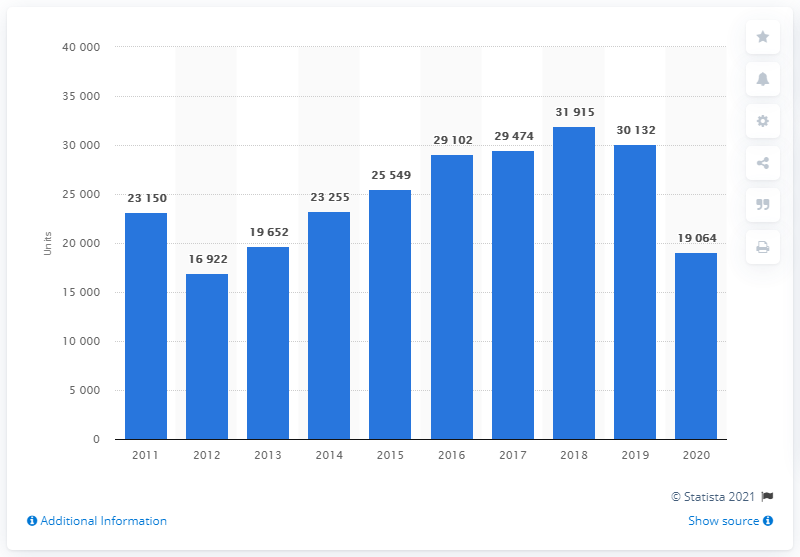Highlight a few significant elements in this photo. In 2020, a total of 19,064 Ford cars were registered in Poland. In 2012, a total of 16,922 Ford cars were registered in Poland. In the year 2011, a total of 23,255 Ford cars were registered in Poland. 